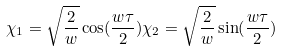Convert formula to latex. <formula><loc_0><loc_0><loc_500><loc_500>\chi _ { 1 } = \sqrt { \frac { 2 } { w } } \cos ( \frac { w \tau } { 2 } ) \chi _ { 2 } = \sqrt { \frac { 2 } { w } } \sin ( \frac { w \tau } { 2 } )</formula> 